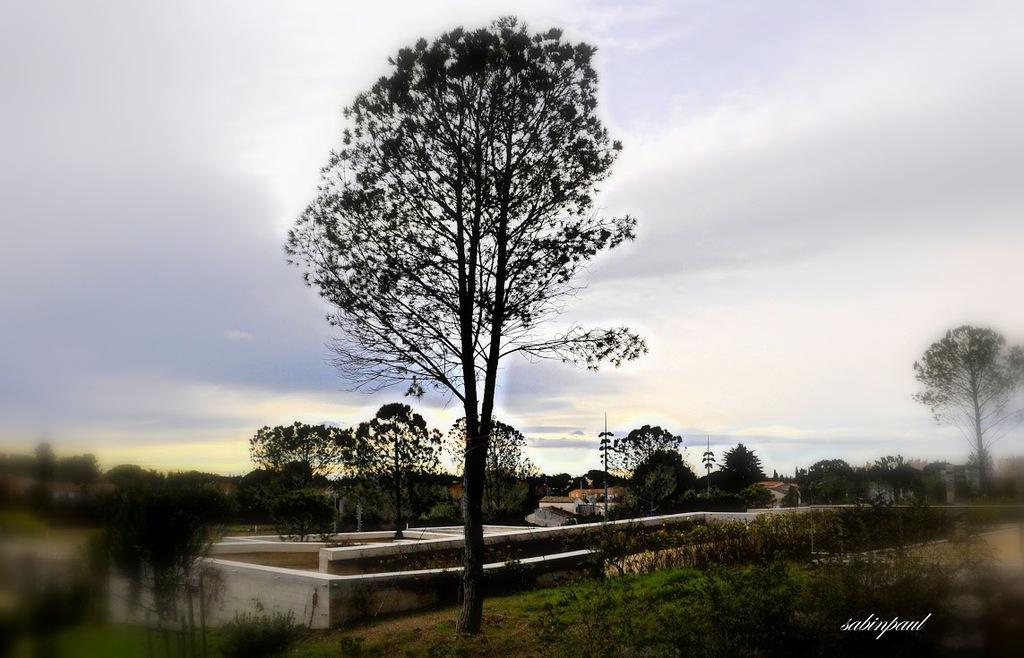What type of vegetation is present in the image? There are many trees in the image. What type of structures can be seen in the image? There are walls in the image. What is the ground covered with in the image? The ground is covered with grass in the image. What can be seen in the background of the image? The sky is visible in the background of the image. What type of glass is used to create the list in the image? There is no glass or list present in the image. How does the coach help the trees in the image? There is no coach present in the image, and the trees do not require assistance. 